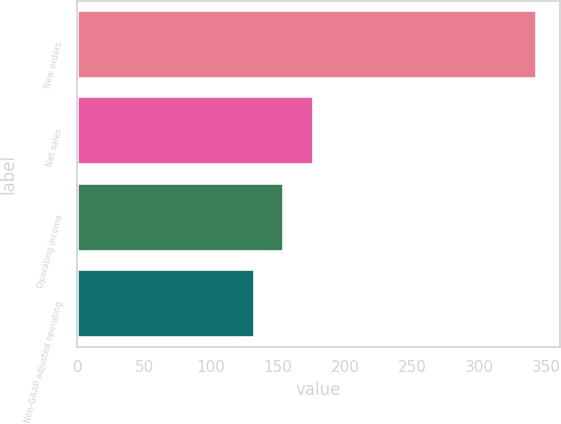Convert chart to OTSL. <chart><loc_0><loc_0><loc_500><loc_500><bar_chart><fcel>New orders<fcel>Net sales<fcel>Operating income<fcel>Non-GAAP adjusted operating<nl><fcel>343<fcel>177<fcel>154<fcel>133<nl></chart> 